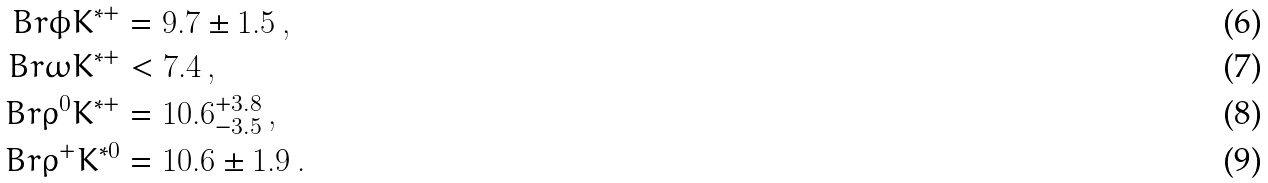<formula> <loc_0><loc_0><loc_500><loc_500>\ B r { \phi K ^ { * + } } & = 9 . 7 \pm 1 . 5 \, , \\ \ B r { \omega K ^ { * + } } & < 7 . 4 \, , \\ \ B r { \rho ^ { 0 } K ^ { * + } } & = 1 0 . 6 ^ { + 3 . 8 } _ { - 3 . 5 } \, , \\ \ B r { \rho ^ { + } K ^ { * 0 } } & = 1 0 . 6 \pm 1 . 9 \, .</formula> 